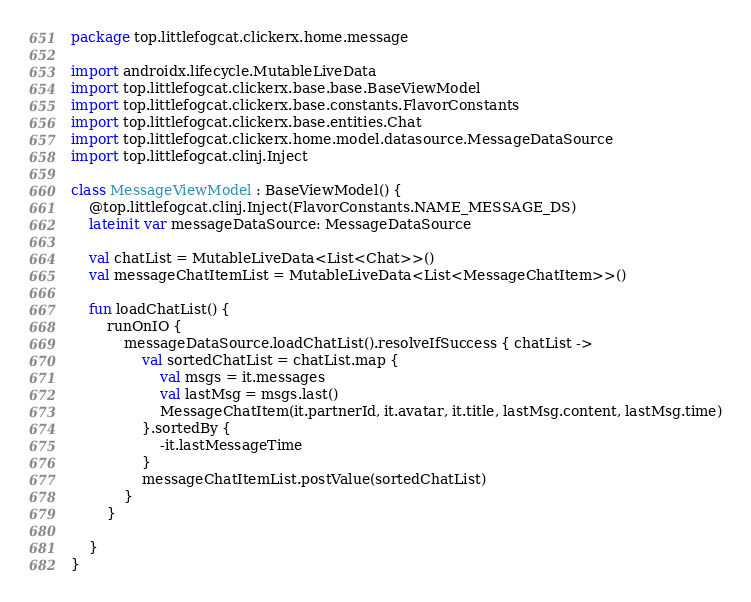<code> <loc_0><loc_0><loc_500><loc_500><_Kotlin_>package top.littlefogcat.clickerx.home.message

import androidx.lifecycle.MutableLiveData
import top.littlefogcat.clickerx.base.base.BaseViewModel
import top.littlefogcat.clickerx.base.constants.FlavorConstants
import top.littlefogcat.clickerx.base.entities.Chat
import top.littlefogcat.clickerx.home.model.datasource.MessageDataSource
import top.littlefogcat.clinj.Inject

class MessageViewModel : BaseViewModel() {
    @top.littlefogcat.clinj.Inject(FlavorConstants.NAME_MESSAGE_DS)
    lateinit var messageDataSource: MessageDataSource

    val chatList = MutableLiveData<List<Chat>>()
    val messageChatItemList = MutableLiveData<List<MessageChatItem>>()

    fun loadChatList() {
        runOnIO {
            messageDataSource.loadChatList().resolveIfSuccess { chatList ->
                val sortedChatList = chatList.map {
                    val msgs = it.messages
                    val lastMsg = msgs.last()
                    MessageChatItem(it.partnerId, it.avatar, it.title, lastMsg.content, lastMsg.time)
                }.sortedBy {
                    -it.lastMessageTime
                }
                messageChatItemList.postValue(sortedChatList)
            }
        }

    }
}</code> 